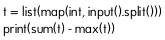Convert code to text. <code><loc_0><loc_0><loc_500><loc_500><_Python_>t = list(map(int, input().split()))
print(sum(t) - max(t))</code> 